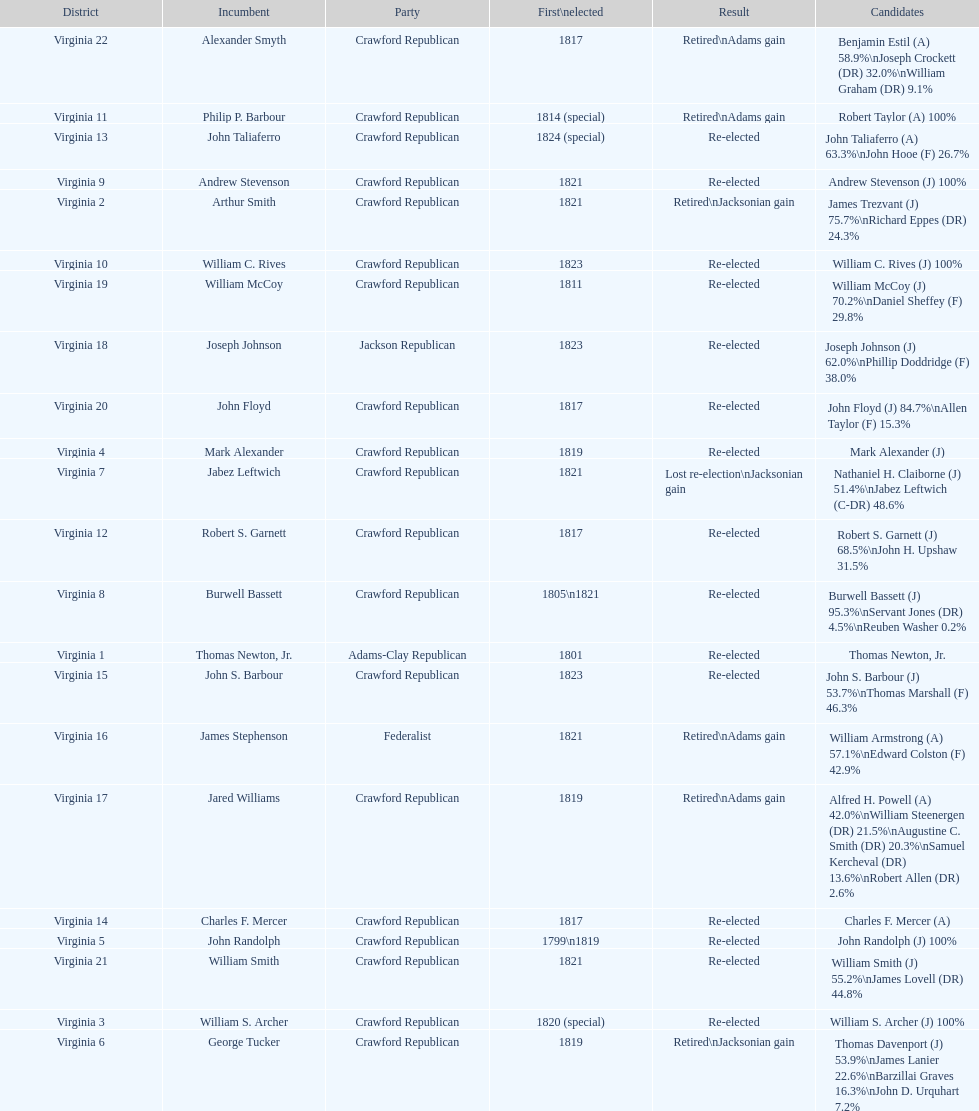Name the only candidate that was first elected in 1811. William McCoy. 